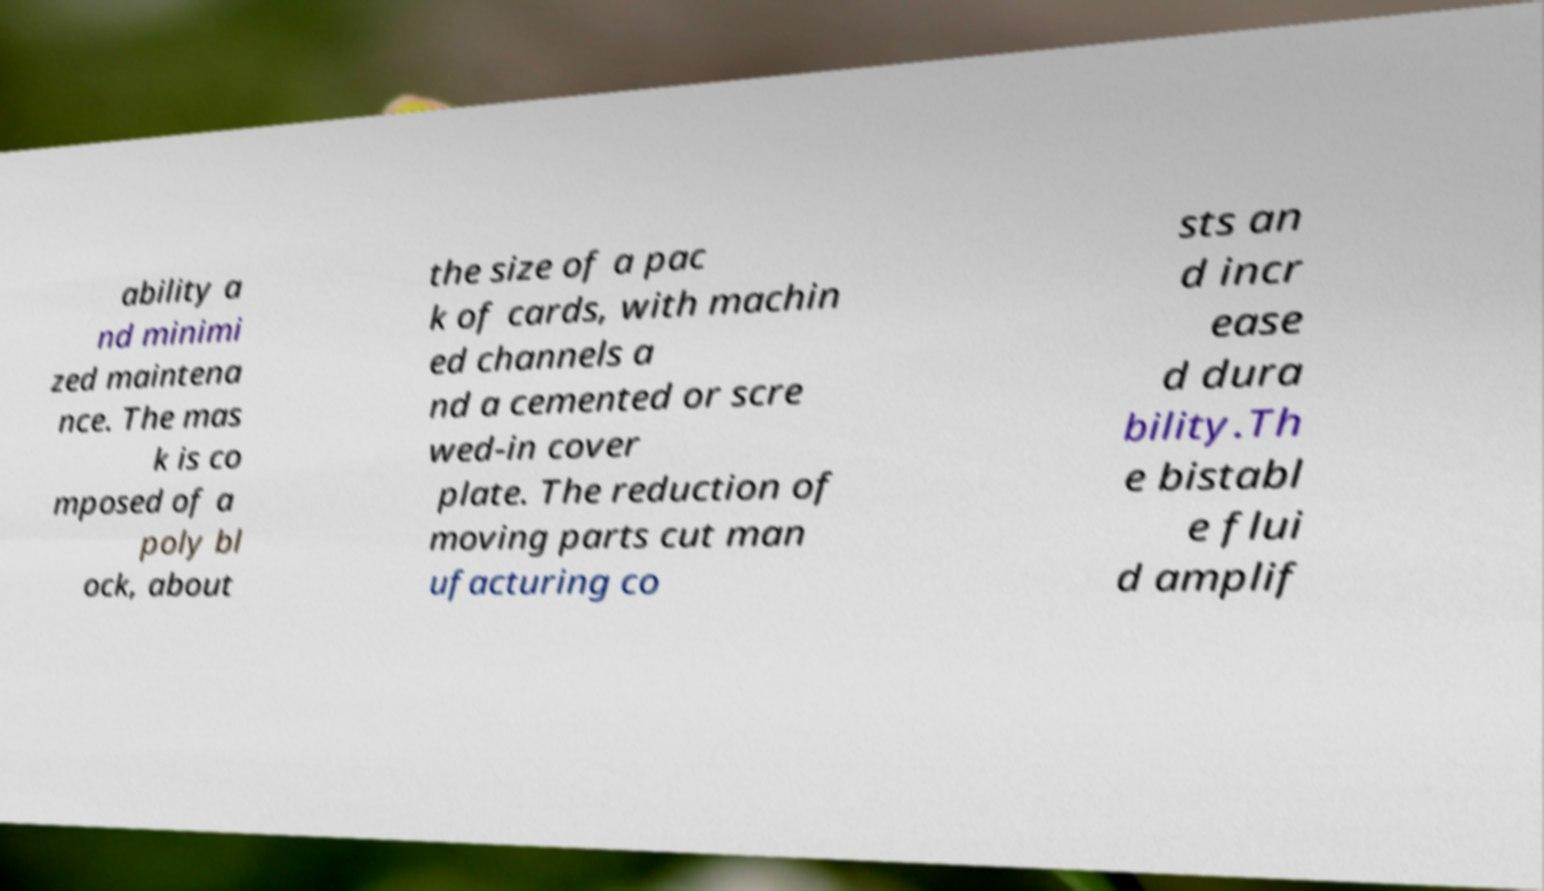I need the written content from this picture converted into text. Can you do that? ability a nd minimi zed maintena nce. The mas k is co mposed of a poly bl ock, about the size of a pac k of cards, with machin ed channels a nd a cemented or scre wed-in cover plate. The reduction of moving parts cut man ufacturing co sts an d incr ease d dura bility.Th e bistabl e flui d amplif 